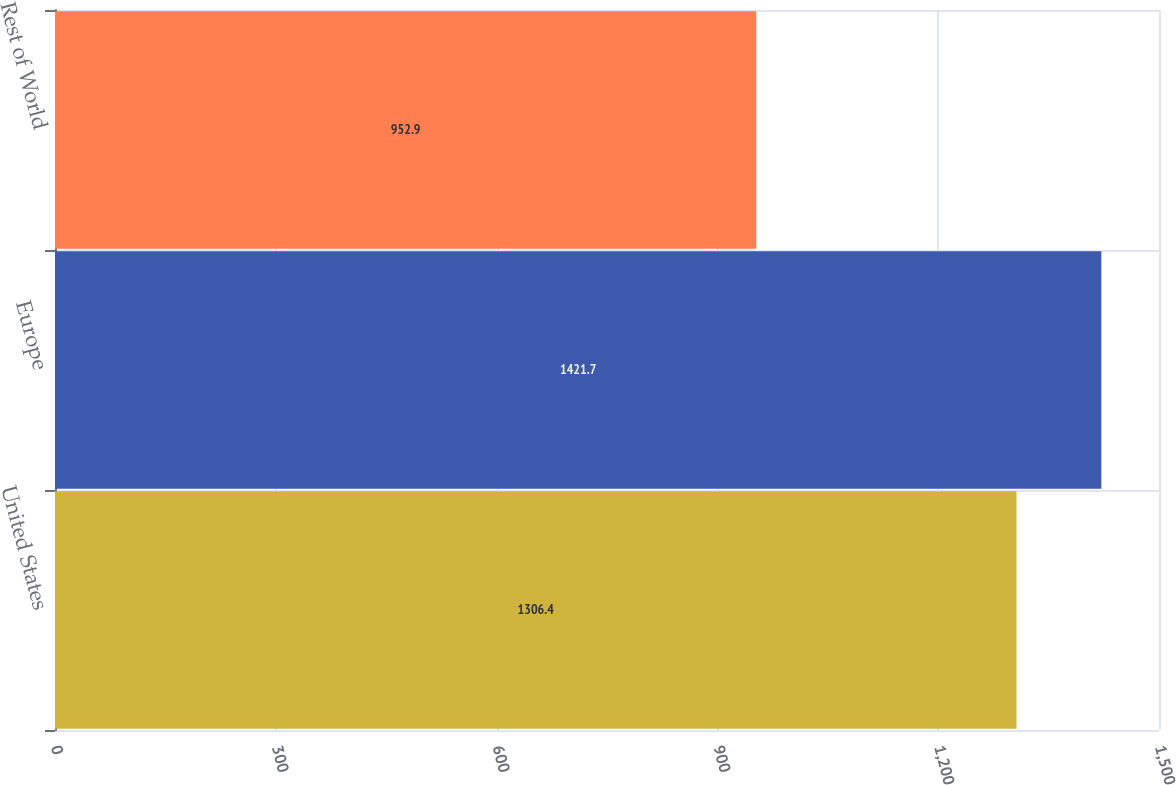Convert chart. <chart><loc_0><loc_0><loc_500><loc_500><bar_chart><fcel>United States<fcel>Europe<fcel>Rest of World<nl><fcel>1306.4<fcel>1421.7<fcel>952.9<nl></chart> 